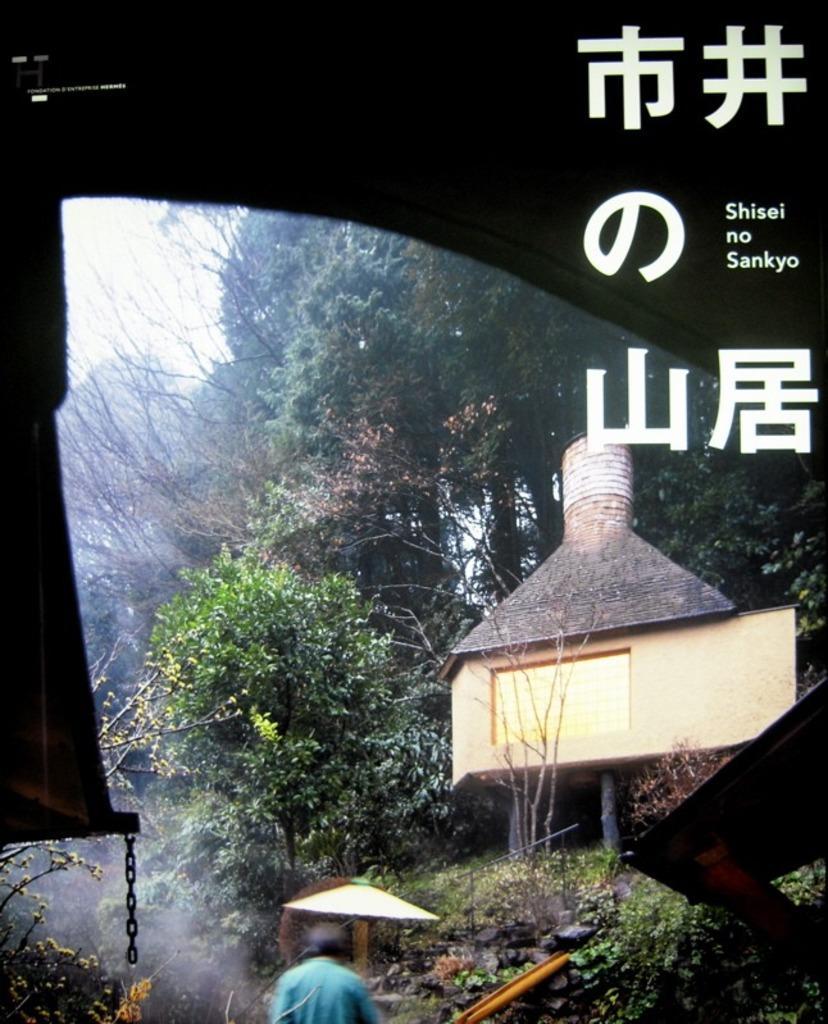Could you give a brief overview of what you see in this image? In this image, we can see so many trees, plants, houses, wall, chain. At the bottom, we can see a human being. Right side of the image, we can see a watermark. 